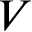Convert formula to latex. <formula><loc_0><loc_0><loc_500><loc_500>V</formula> 